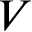Convert formula to latex. <formula><loc_0><loc_0><loc_500><loc_500>V</formula> 